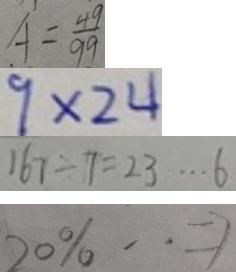<formula> <loc_0><loc_0><loc_500><loc_500>A = \frac { 4 9 } { 9 9 } 
 9 \times 2 4 
 1 6 7 \div 7 = 2 3 \cdots 6 
 2 0 \% \cdot = 7</formula> 